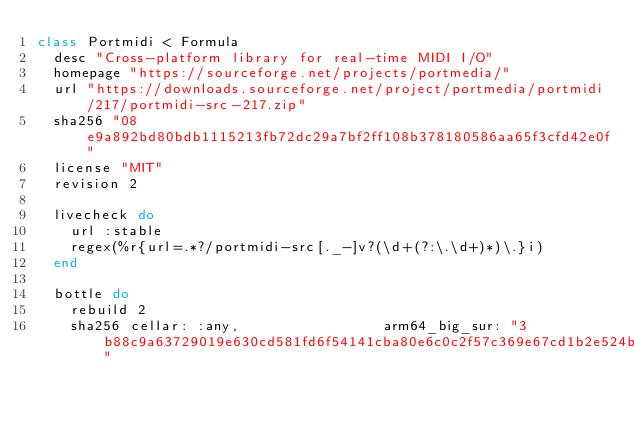Convert code to text. <code><loc_0><loc_0><loc_500><loc_500><_Ruby_>class Portmidi < Formula
  desc "Cross-platform library for real-time MIDI I/O"
  homepage "https://sourceforge.net/projects/portmedia/"
  url "https://downloads.sourceforge.net/project/portmedia/portmidi/217/portmidi-src-217.zip"
  sha256 "08e9a892bd80bdb1115213fb72dc29a7bf2ff108b378180586aa65f3cfd42e0f"
  license "MIT"
  revision 2

  livecheck do
    url :stable
    regex(%r{url=.*?/portmidi-src[._-]v?(\d+(?:\.\d+)*)\.}i)
  end

  bottle do
    rebuild 2
    sha256 cellar: :any,                 arm64_big_sur: "3b88c9a63729019e630cd581fd6f54141cba80e6c0c2f57c369e67cd1b2e524b"</code> 